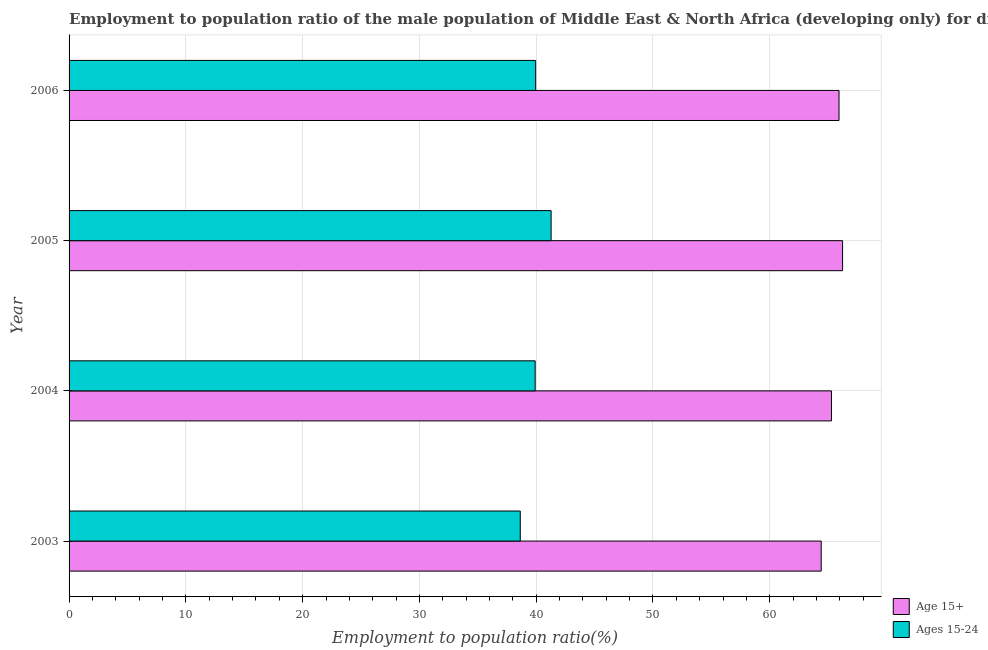How many different coloured bars are there?
Your answer should be compact. 2. How many groups of bars are there?
Provide a short and direct response. 4. Are the number of bars per tick equal to the number of legend labels?
Your answer should be very brief. Yes. Are the number of bars on each tick of the Y-axis equal?
Your answer should be very brief. Yes. How many bars are there on the 4th tick from the bottom?
Offer a very short reply. 2. What is the label of the 4th group of bars from the top?
Make the answer very short. 2003. In how many cases, is the number of bars for a given year not equal to the number of legend labels?
Provide a succinct answer. 0. What is the employment to population ratio(age 15+) in 2003?
Ensure brevity in your answer.  64.4. Across all years, what is the maximum employment to population ratio(age 15+)?
Give a very brief answer. 66.23. Across all years, what is the minimum employment to population ratio(age 15-24)?
Give a very brief answer. 38.63. In which year was the employment to population ratio(age 15+) maximum?
Provide a succinct answer. 2005. In which year was the employment to population ratio(age 15-24) minimum?
Provide a succinct answer. 2003. What is the total employment to population ratio(age 15-24) in the graph?
Your response must be concise. 159.78. What is the difference between the employment to population ratio(age 15-24) in 2003 and that in 2006?
Ensure brevity in your answer.  -1.32. What is the difference between the employment to population ratio(age 15+) in 2006 and the employment to population ratio(age 15-24) in 2005?
Offer a terse response. 24.65. What is the average employment to population ratio(age 15+) per year?
Provide a short and direct response. 65.46. In the year 2004, what is the difference between the employment to population ratio(age 15+) and employment to population ratio(age 15-24)?
Your answer should be very brief. 25.37. Is the difference between the employment to population ratio(age 15-24) in 2005 and 2006 greater than the difference between the employment to population ratio(age 15+) in 2005 and 2006?
Keep it short and to the point. Yes. What is the difference between the highest and the second highest employment to population ratio(age 15+)?
Give a very brief answer. 0.31. What is the difference between the highest and the lowest employment to population ratio(age 15-24)?
Give a very brief answer. 2.64. What does the 1st bar from the top in 2003 represents?
Offer a terse response. Ages 15-24. What does the 2nd bar from the bottom in 2006 represents?
Your answer should be compact. Ages 15-24. How many bars are there?
Make the answer very short. 8. Are all the bars in the graph horizontal?
Offer a terse response. Yes. How many years are there in the graph?
Your answer should be compact. 4. What is the difference between two consecutive major ticks on the X-axis?
Ensure brevity in your answer.  10. Are the values on the major ticks of X-axis written in scientific E-notation?
Your answer should be very brief. No. Does the graph contain grids?
Your response must be concise. Yes. What is the title of the graph?
Your answer should be compact. Employment to population ratio of the male population of Middle East & North Africa (developing only) for different age-groups. Does "Central government" appear as one of the legend labels in the graph?
Your answer should be compact. No. What is the label or title of the X-axis?
Your response must be concise. Employment to population ratio(%). What is the label or title of the Y-axis?
Offer a very short reply. Year. What is the Employment to population ratio(%) in Age 15+ in 2003?
Make the answer very short. 64.4. What is the Employment to population ratio(%) of Ages 15-24 in 2003?
Ensure brevity in your answer.  38.63. What is the Employment to population ratio(%) in Age 15+ in 2004?
Provide a succinct answer. 65.28. What is the Employment to population ratio(%) in Ages 15-24 in 2004?
Your answer should be compact. 39.91. What is the Employment to population ratio(%) in Age 15+ in 2005?
Provide a short and direct response. 66.23. What is the Employment to population ratio(%) in Ages 15-24 in 2005?
Keep it short and to the point. 41.28. What is the Employment to population ratio(%) of Age 15+ in 2006?
Make the answer very short. 65.93. What is the Employment to population ratio(%) in Ages 15-24 in 2006?
Offer a terse response. 39.95. Across all years, what is the maximum Employment to population ratio(%) of Age 15+?
Keep it short and to the point. 66.23. Across all years, what is the maximum Employment to population ratio(%) of Ages 15-24?
Offer a very short reply. 41.28. Across all years, what is the minimum Employment to population ratio(%) in Age 15+?
Offer a terse response. 64.4. Across all years, what is the minimum Employment to population ratio(%) in Ages 15-24?
Offer a terse response. 38.63. What is the total Employment to population ratio(%) in Age 15+ in the graph?
Offer a terse response. 261.85. What is the total Employment to population ratio(%) of Ages 15-24 in the graph?
Provide a short and direct response. 159.78. What is the difference between the Employment to population ratio(%) in Age 15+ in 2003 and that in 2004?
Provide a succinct answer. -0.88. What is the difference between the Employment to population ratio(%) of Ages 15-24 in 2003 and that in 2004?
Keep it short and to the point. -1.28. What is the difference between the Employment to population ratio(%) in Age 15+ in 2003 and that in 2005?
Your response must be concise. -1.83. What is the difference between the Employment to population ratio(%) in Ages 15-24 in 2003 and that in 2005?
Provide a short and direct response. -2.64. What is the difference between the Employment to population ratio(%) in Age 15+ in 2003 and that in 2006?
Your answer should be very brief. -1.53. What is the difference between the Employment to population ratio(%) of Ages 15-24 in 2003 and that in 2006?
Your response must be concise. -1.32. What is the difference between the Employment to population ratio(%) of Age 15+ in 2004 and that in 2005?
Your answer should be compact. -0.95. What is the difference between the Employment to population ratio(%) in Ages 15-24 in 2004 and that in 2005?
Your response must be concise. -1.37. What is the difference between the Employment to population ratio(%) of Age 15+ in 2004 and that in 2006?
Give a very brief answer. -0.65. What is the difference between the Employment to population ratio(%) of Ages 15-24 in 2004 and that in 2006?
Ensure brevity in your answer.  -0.04. What is the difference between the Employment to population ratio(%) of Age 15+ in 2005 and that in 2006?
Ensure brevity in your answer.  0.31. What is the difference between the Employment to population ratio(%) of Ages 15-24 in 2005 and that in 2006?
Ensure brevity in your answer.  1.32. What is the difference between the Employment to population ratio(%) in Age 15+ in 2003 and the Employment to population ratio(%) in Ages 15-24 in 2004?
Offer a terse response. 24.49. What is the difference between the Employment to population ratio(%) in Age 15+ in 2003 and the Employment to population ratio(%) in Ages 15-24 in 2005?
Your answer should be very brief. 23.13. What is the difference between the Employment to population ratio(%) of Age 15+ in 2003 and the Employment to population ratio(%) of Ages 15-24 in 2006?
Your answer should be very brief. 24.45. What is the difference between the Employment to population ratio(%) of Age 15+ in 2004 and the Employment to population ratio(%) of Ages 15-24 in 2005?
Offer a terse response. 24.01. What is the difference between the Employment to population ratio(%) in Age 15+ in 2004 and the Employment to population ratio(%) in Ages 15-24 in 2006?
Offer a terse response. 25.33. What is the difference between the Employment to population ratio(%) in Age 15+ in 2005 and the Employment to population ratio(%) in Ages 15-24 in 2006?
Provide a short and direct response. 26.28. What is the average Employment to population ratio(%) in Age 15+ per year?
Offer a very short reply. 65.46. What is the average Employment to population ratio(%) of Ages 15-24 per year?
Your answer should be very brief. 39.94. In the year 2003, what is the difference between the Employment to population ratio(%) in Age 15+ and Employment to population ratio(%) in Ages 15-24?
Keep it short and to the point. 25.77. In the year 2004, what is the difference between the Employment to population ratio(%) of Age 15+ and Employment to population ratio(%) of Ages 15-24?
Keep it short and to the point. 25.37. In the year 2005, what is the difference between the Employment to population ratio(%) in Age 15+ and Employment to population ratio(%) in Ages 15-24?
Offer a very short reply. 24.96. In the year 2006, what is the difference between the Employment to population ratio(%) of Age 15+ and Employment to population ratio(%) of Ages 15-24?
Your answer should be compact. 25.98. What is the ratio of the Employment to population ratio(%) of Age 15+ in 2003 to that in 2004?
Ensure brevity in your answer.  0.99. What is the ratio of the Employment to population ratio(%) of Age 15+ in 2003 to that in 2005?
Your answer should be very brief. 0.97. What is the ratio of the Employment to population ratio(%) in Ages 15-24 in 2003 to that in 2005?
Your answer should be compact. 0.94. What is the ratio of the Employment to population ratio(%) in Age 15+ in 2003 to that in 2006?
Provide a succinct answer. 0.98. What is the ratio of the Employment to population ratio(%) in Age 15+ in 2004 to that in 2005?
Offer a very short reply. 0.99. What is the ratio of the Employment to population ratio(%) of Ages 15-24 in 2004 to that in 2005?
Provide a short and direct response. 0.97. What is the ratio of the Employment to population ratio(%) in Age 15+ in 2004 to that in 2006?
Provide a short and direct response. 0.99. What is the ratio of the Employment to population ratio(%) of Ages 15-24 in 2005 to that in 2006?
Your response must be concise. 1.03. What is the difference between the highest and the second highest Employment to population ratio(%) in Age 15+?
Your answer should be very brief. 0.31. What is the difference between the highest and the second highest Employment to population ratio(%) in Ages 15-24?
Give a very brief answer. 1.32. What is the difference between the highest and the lowest Employment to population ratio(%) of Age 15+?
Offer a very short reply. 1.83. What is the difference between the highest and the lowest Employment to population ratio(%) in Ages 15-24?
Make the answer very short. 2.64. 